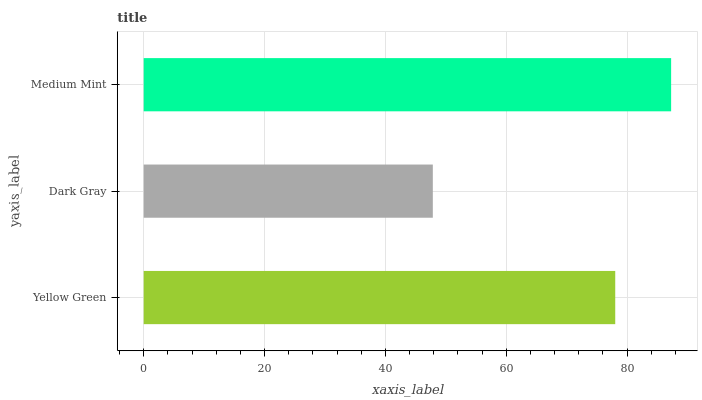Is Dark Gray the minimum?
Answer yes or no. Yes. Is Medium Mint the maximum?
Answer yes or no. Yes. Is Medium Mint the minimum?
Answer yes or no. No. Is Dark Gray the maximum?
Answer yes or no. No. Is Medium Mint greater than Dark Gray?
Answer yes or no. Yes. Is Dark Gray less than Medium Mint?
Answer yes or no. Yes. Is Dark Gray greater than Medium Mint?
Answer yes or no. No. Is Medium Mint less than Dark Gray?
Answer yes or no. No. Is Yellow Green the high median?
Answer yes or no. Yes. Is Yellow Green the low median?
Answer yes or no. Yes. Is Medium Mint the high median?
Answer yes or no. No. Is Medium Mint the low median?
Answer yes or no. No. 